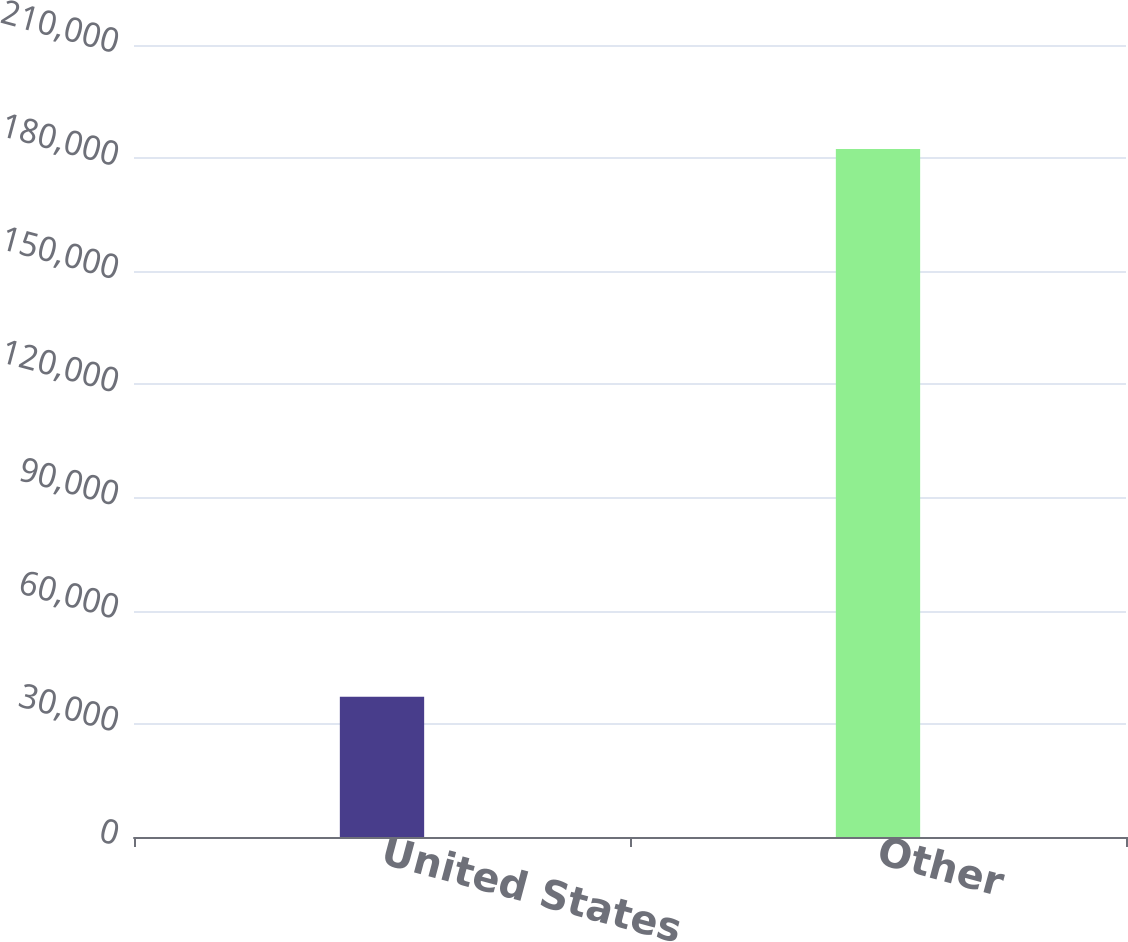Convert chart to OTSL. <chart><loc_0><loc_0><loc_500><loc_500><bar_chart><fcel>United States<fcel>Other<nl><fcel>37201<fcel>182427<nl></chart> 